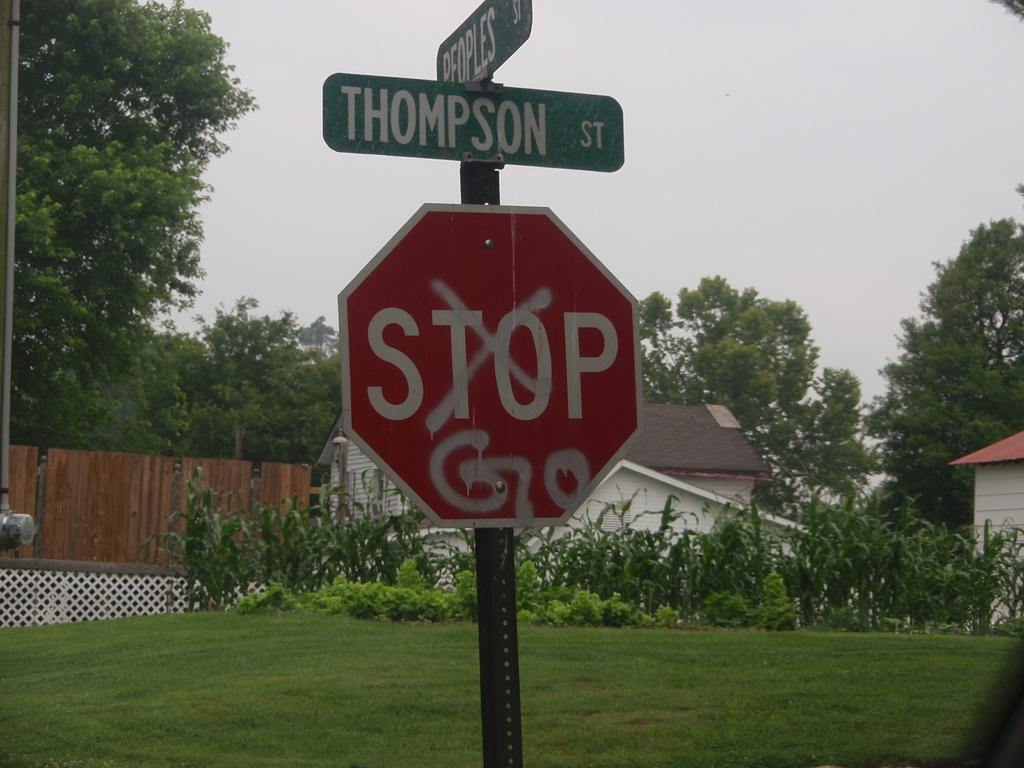<image>
Describe the image concisely. Someone crossed off the word 'stop' on a stop sign and wrote the word 'go' underneath it. 